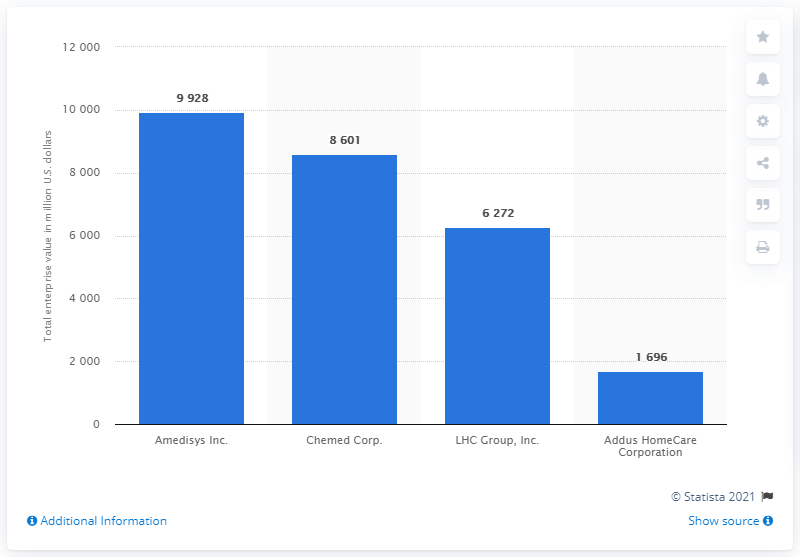List a handful of essential elements in this visual. As of January 31, 2021, Amedisys was worth approximately 9,928 dollars in U.S. currency. 